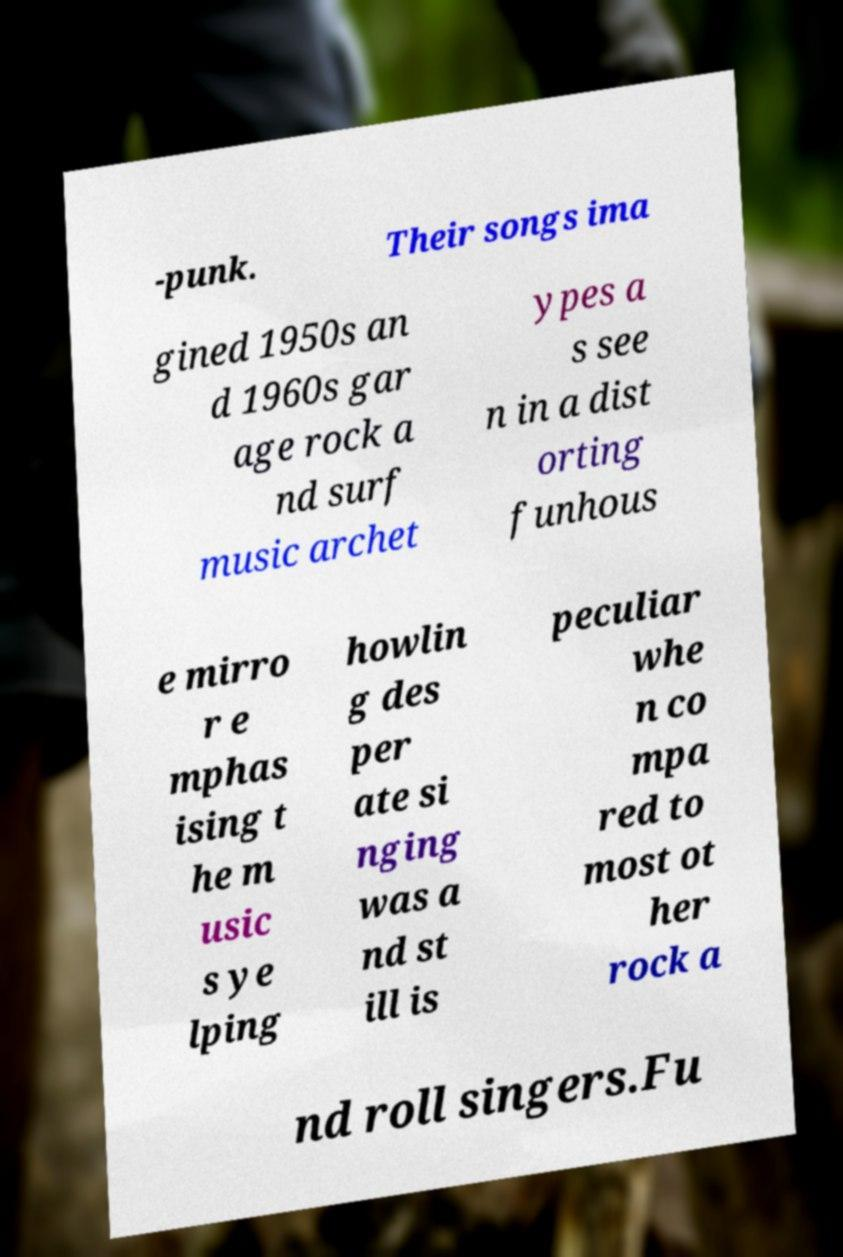Could you assist in decoding the text presented in this image and type it out clearly? -punk. Their songs ima gined 1950s an d 1960s gar age rock a nd surf music archet ypes a s see n in a dist orting funhous e mirro r e mphas ising t he m usic s ye lping howlin g des per ate si nging was a nd st ill is peculiar whe n co mpa red to most ot her rock a nd roll singers.Fu 